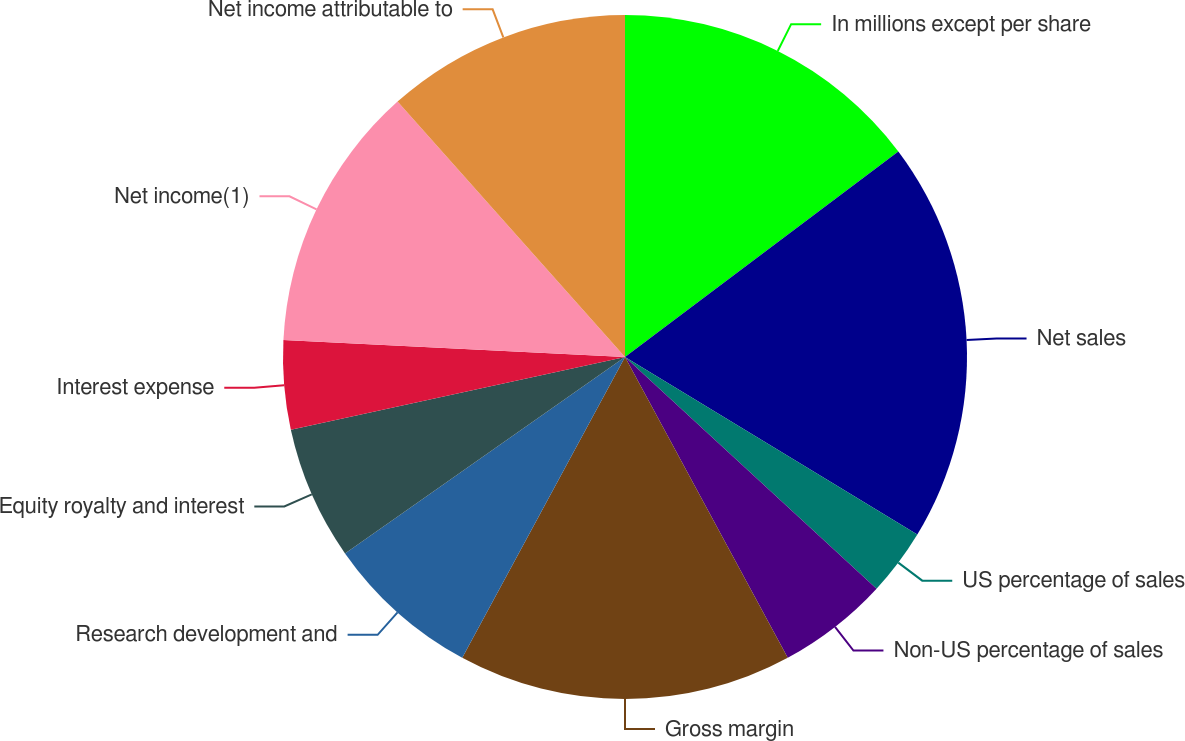<chart> <loc_0><loc_0><loc_500><loc_500><pie_chart><fcel>In millions except per share<fcel>Net sales<fcel>US percentage of sales<fcel>Non-US percentage of sales<fcel>Gross margin<fcel>Research development and<fcel>Equity royalty and interest<fcel>Interest expense<fcel>Net income(1)<fcel>Net income attributable to<nl><fcel>14.74%<fcel>18.95%<fcel>3.16%<fcel>5.26%<fcel>15.79%<fcel>7.37%<fcel>6.32%<fcel>4.21%<fcel>12.63%<fcel>11.58%<nl></chart> 